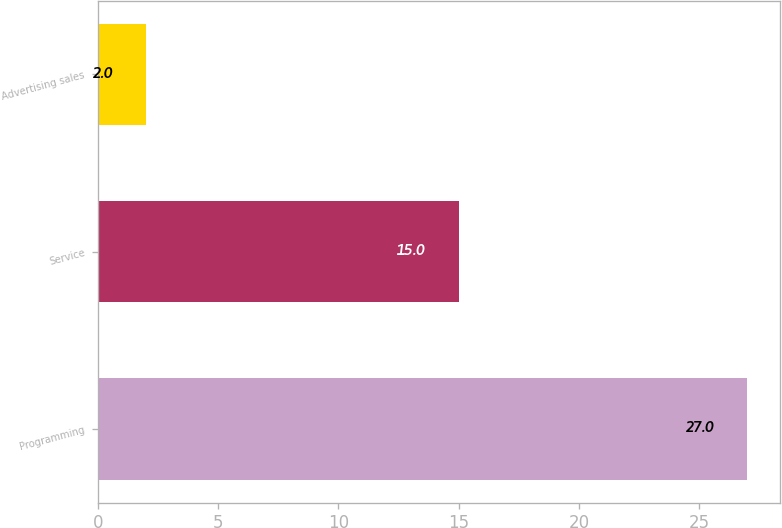<chart> <loc_0><loc_0><loc_500><loc_500><bar_chart><fcel>Programming<fcel>Service<fcel>Advertising sales<nl><fcel>27<fcel>15<fcel>2<nl></chart> 